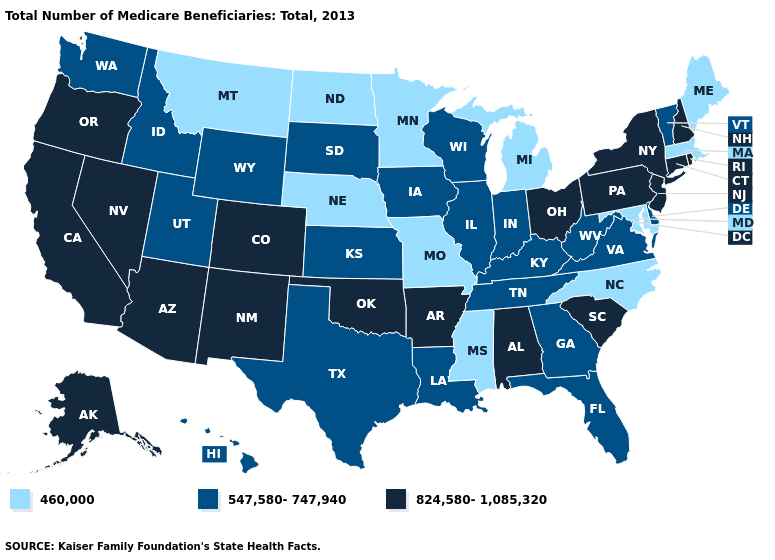Name the states that have a value in the range 460,000?
Be succinct. Maine, Maryland, Massachusetts, Michigan, Minnesota, Mississippi, Missouri, Montana, Nebraska, North Carolina, North Dakota. Does Washington have a lower value than Alabama?
Write a very short answer. Yes. Does the first symbol in the legend represent the smallest category?
Answer briefly. Yes. Name the states that have a value in the range 460,000?
Write a very short answer. Maine, Maryland, Massachusetts, Michigan, Minnesota, Mississippi, Missouri, Montana, Nebraska, North Carolina, North Dakota. What is the lowest value in the USA?
Concise answer only. 460,000. Which states have the lowest value in the USA?
Answer briefly. Maine, Maryland, Massachusetts, Michigan, Minnesota, Mississippi, Missouri, Montana, Nebraska, North Carolina, North Dakota. What is the value of Minnesota?
Give a very brief answer. 460,000. Name the states that have a value in the range 547,580-747,940?
Quick response, please. Delaware, Florida, Georgia, Hawaii, Idaho, Illinois, Indiana, Iowa, Kansas, Kentucky, Louisiana, South Dakota, Tennessee, Texas, Utah, Vermont, Virginia, Washington, West Virginia, Wisconsin, Wyoming. What is the value of Maine?
Answer briefly. 460,000. Name the states that have a value in the range 547,580-747,940?
Concise answer only. Delaware, Florida, Georgia, Hawaii, Idaho, Illinois, Indiana, Iowa, Kansas, Kentucky, Louisiana, South Dakota, Tennessee, Texas, Utah, Vermont, Virginia, Washington, West Virginia, Wisconsin, Wyoming. Name the states that have a value in the range 460,000?
Answer briefly. Maine, Maryland, Massachusetts, Michigan, Minnesota, Mississippi, Missouri, Montana, Nebraska, North Carolina, North Dakota. Does South Dakota have the same value as Maine?
Write a very short answer. No. Does Ohio have the highest value in the MidWest?
Short answer required. Yes. What is the value of Missouri?
Short answer required. 460,000. Which states hav the highest value in the West?
Write a very short answer. Alaska, Arizona, California, Colorado, Nevada, New Mexico, Oregon. 